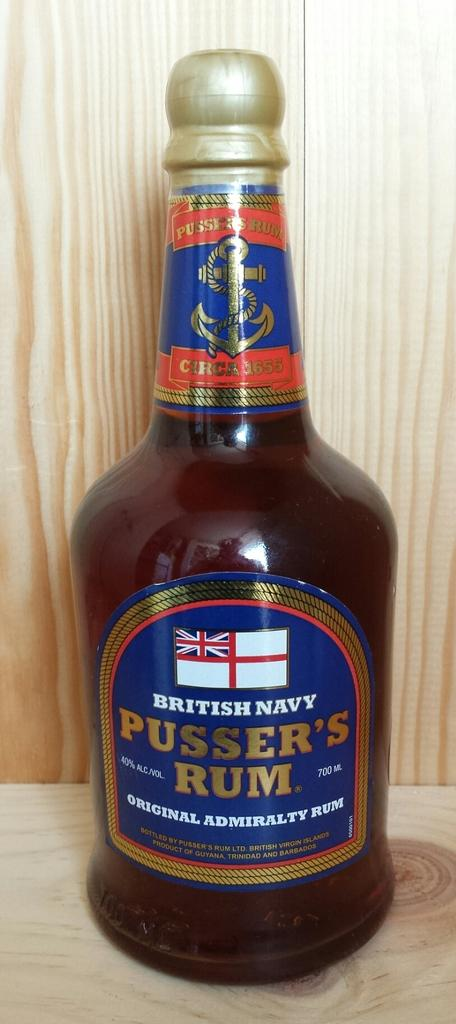<image>
Render a clear and concise summary of the photo. A full bottle of Pusser's Rum sits on a wood surface. 